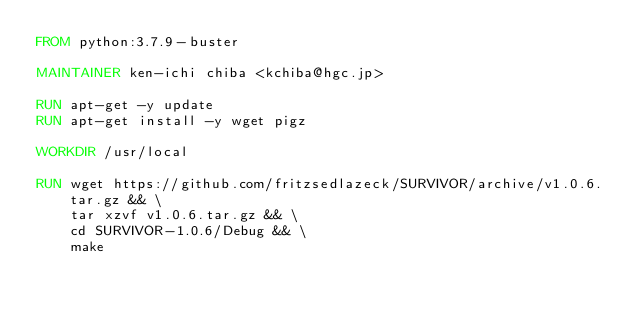Convert code to text. <code><loc_0><loc_0><loc_500><loc_500><_Dockerfile_>FROM python:3.7.9-buster

MAINTAINER ken-ichi chiba <kchiba@hgc.jp>

RUN apt-get -y update
RUN apt-get install -y wget pigz

WORKDIR /usr/local

RUN wget https://github.com/fritzsedlazeck/SURVIVOR/archive/v1.0.6.tar.gz && \
    tar xzvf v1.0.6.tar.gz && \
    cd SURVIVOR-1.0.6/Debug && \
    make
</code> 